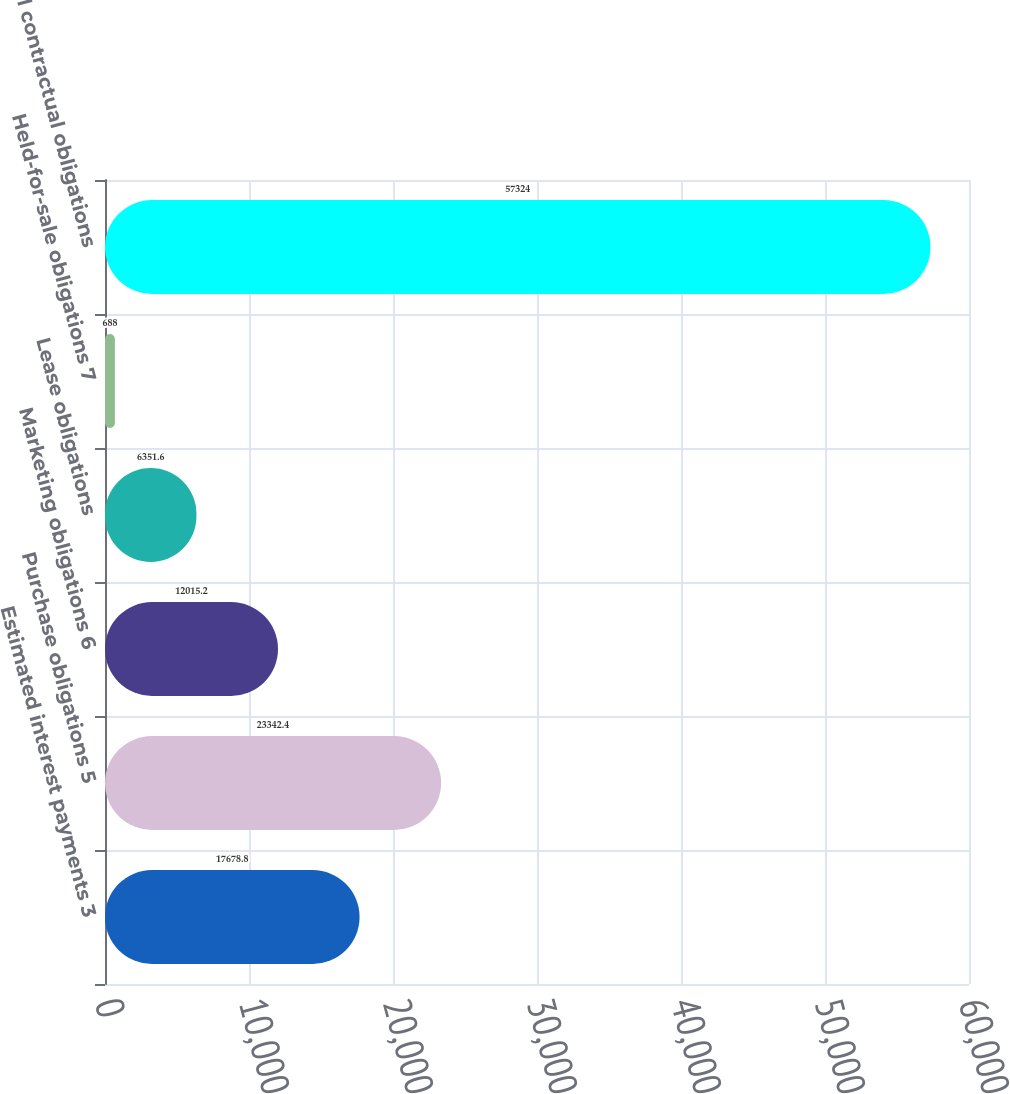Convert chart to OTSL. <chart><loc_0><loc_0><loc_500><loc_500><bar_chart><fcel>Estimated interest payments 3<fcel>Purchase obligations 5<fcel>Marketing obligations 6<fcel>Lease obligations<fcel>Held-for-sale obligations 7<fcel>Total contractual obligations<nl><fcel>17678.8<fcel>23342.4<fcel>12015.2<fcel>6351.6<fcel>688<fcel>57324<nl></chart> 